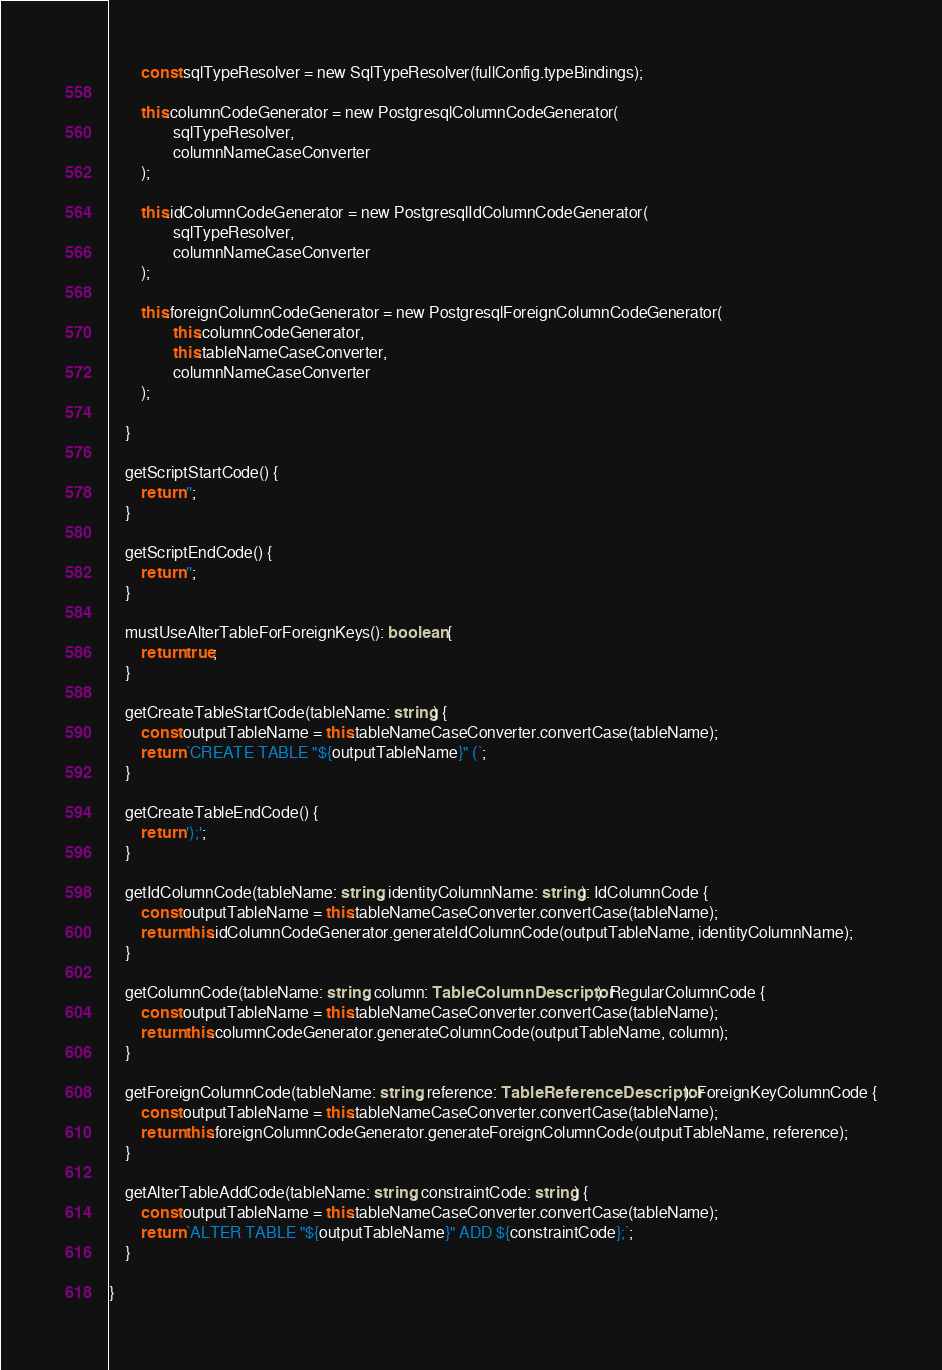Convert code to text. <code><loc_0><loc_0><loc_500><loc_500><_TypeScript_>		const sqlTypeResolver = new SqlTypeResolver(fullConfig.typeBindings);

		this.columnCodeGenerator = new PostgresqlColumnCodeGenerator(
				sqlTypeResolver,
				columnNameCaseConverter
		);

		this.idColumnCodeGenerator = new PostgresqlIdColumnCodeGenerator(
				sqlTypeResolver,
				columnNameCaseConverter
		);

		this.foreignColumnCodeGenerator = new PostgresqlForeignColumnCodeGenerator(
				this.columnCodeGenerator,
				this.tableNameCaseConverter,
				columnNameCaseConverter
		);

	}

	getScriptStartCode() {
		return '';
	}

	getScriptEndCode() {
		return '';
	}

	mustUseAlterTableForForeignKeys(): boolean {
		return true;
	}

	getCreateTableStartCode(tableName: string) {
		const outputTableName = this.tableNameCaseConverter.convertCase(tableName);
		return `CREATE TABLE "${outputTableName}" (`;
	}

	getCreateTableEndCode() {
		return ');';
	}

	getIdColumnCode(tableName: string, identityColumnName: string): IdColumnCode {
		const outputTableName = this.tableNameCaseConverter.convertCase(tableName);
		return this.idColumnCodeGenerator.generateIdColumnCode(outputTableName, identityColumnName);
	}

	getColumnCode(tableName: string, column: TableColumnDescriptor): RegularColumnCode {
		const outputTableName = this.tableNameCaseConverter.convertCase(tableName);
		return this.columnCodeGenerator.generateColumnCode(outputTableName, column);
	}

	getForeignColumnCode(tableName: string, reference: TableReferenceDescriptor): ForeignKeyColumnCode {
		const outputTableName = this.tableNameCaseConverter.convertCase(tableName);
		return this.foreignColumnCodeGenerator.generateForeignColumnCode(outputTableName, reference);
	}

	getAlterTableAddCode(tableName: string, constraintCode: string) {
		const outputTableName = this.tableNameCaseConverter.convertCase(tableName);
		return `ALTER TABLE "${outputTableName}" ADD ${constraintCode};`;
	}

}
</code> 